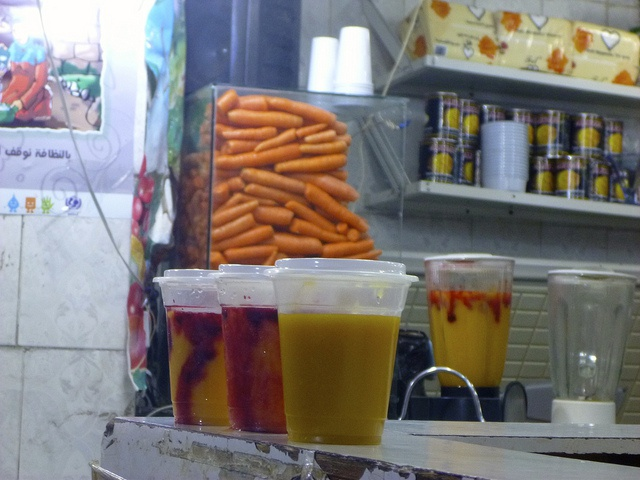Describe the objects in this image and their specific colors. I can see carrot in violet, brown, gray, and maroon tones, cup in violet, olive, darkgray, and maroon tones, cup in violet, olive, gray, black, and maroon tones, cup in violet, gray, darkgray, and darkgreen tones, and cup in violet, maroon, darkgray, and black tones in this image. 